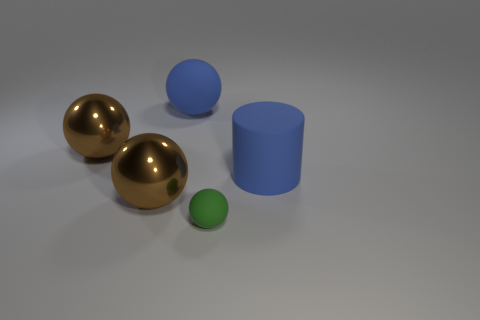How many large things are blue cylinders or matte balls?
Keep it short and to the point. 2. There is a brown sphere behind the blue cylinder; what size is it?
Ensure brevity in your answer.  Large. Is there a matte thing of the same color as the tiny sphere?
Provide a short and direct response. No. Is the color of the matte cylinder the same as the big rubber sphere?
Give a very brief answer. Yes. There is a big matte thing that is the same color as the large rubber sphere; what shape is it?
Provide a short and direct response. Cylinder. What number of blue matte balls are on the left side of the brown metallic ball in front of the big blue cylinder?
Your response must be concise. 0. What number of small balls have the same material as the big cylinder?
Your answer should be compact. 1. Are there any big cylinders right of the big matte sphere?
Offer a very short reply. Yes. What is the color of the rubber object that is the same size as the cylinder?
Ensure brevity in your answer.  Blue. How many things are things behind the tiny thing or blue matte balls?
Ensure brevity in your answer.  4. 